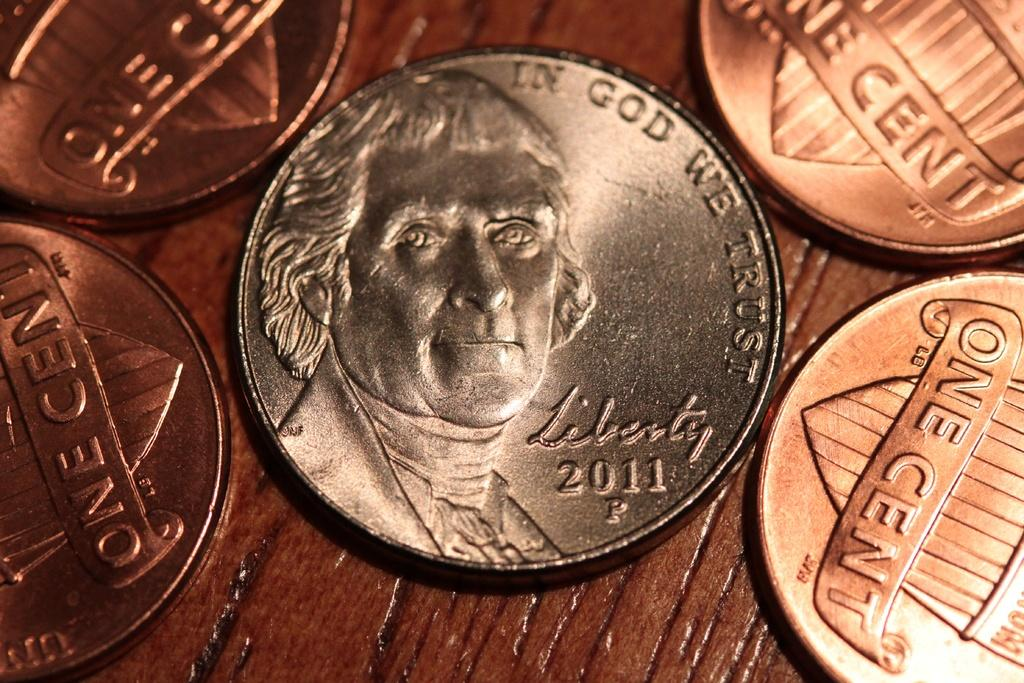<image>
Create a compact narrative representing the image presented. Coin showing a president's face and the year 2011. 